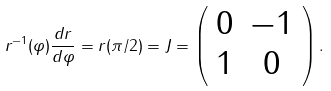<formula> <loc_0><loc_0><loc_500><loc_500>r ^ { - 1 } ( \varphi ) \frac { d r } { d \varphi } = r ( \pi / 2 ) = J = \left ( \begin{array} { c c } 0 & - 1 \\ 1 & 0 \end{array} \right ) .</formula> 